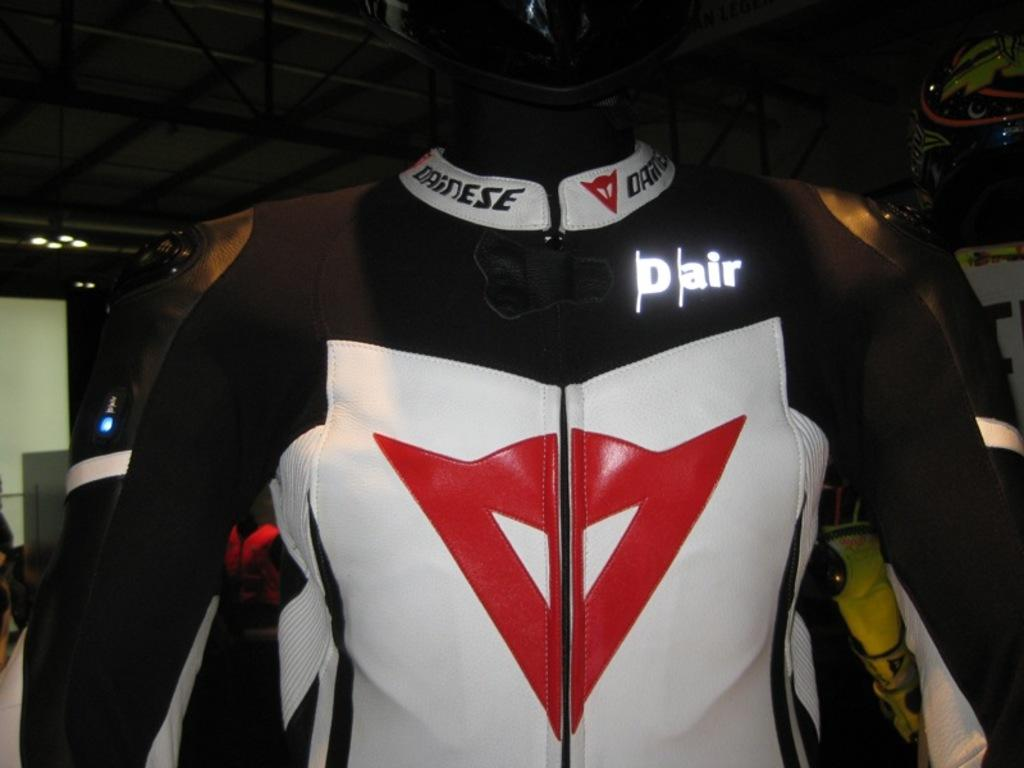What is the mannequin wearing in the image? The mannequin is wearing a dress in the image. Who else can be seen in the image besides the mannequin? A person wearing a helmet is visible in the image. What type of structure can be seen in the image? There are metal poles and a roof with ceiling lights in the image. Where is the throne located in the image? There is no throne present in the image. What type of ground can be seen in the image? The ground is not visible in the image; only the mannequin, the person wearing a helmet, metal poles, and the roof with ceiling lights can be seen. 